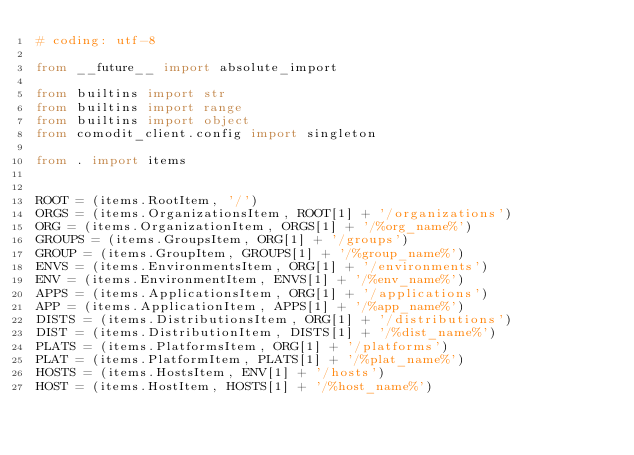Convert code to text. <code><loc_0><loc_0><loc_500><loc_500><_Python_># coding: utf-8

from __future__ import absolute_import

from builtins import str
from builtins import range
from builtins import object
from comodit_client.config import singleton

from . import items


ROOT = (items.RootItem, '/')
ORGS = (items.OrganizationsItem, ROOT[1] + '/organizations')
ORG = (items.OrganizationItem, ORGS[1] + '/%org_name%')
GROUPS = (items.GroupsItem, ORG[1] + '/groups')
GROUP = (items.GroupItem, GROUPS[1] + '/%group_name%')
ENVS = (items.EnvironmentsItem, ORG[1] + '/environments')
ENV = (items.EnvironmentItem, ENVS[1] + '/%env_name%')
APPS = (items.ApplicationsItem, ORG[1] + '/applications')
APP = (items.ApplicationItem, APPS[1] + '/%app_name%')
DISTS = (items.DistributionsItem, ORG[1] + '/distributions')
DIST = (items.DistributionItem, DISTS[1] + '/%dist_name%')
PLATS = (items.PlatformsItem, ORG[1] + '/platforms')
PLAT = (items.PlatformItem, PLATS[1] + '/%plat_name%')
HOSTS = (items.HostsItem, ENV[1] + '/hosts')
HOST = (items.HostItem, HOSTS[1] + '/%host_name%')</code> 